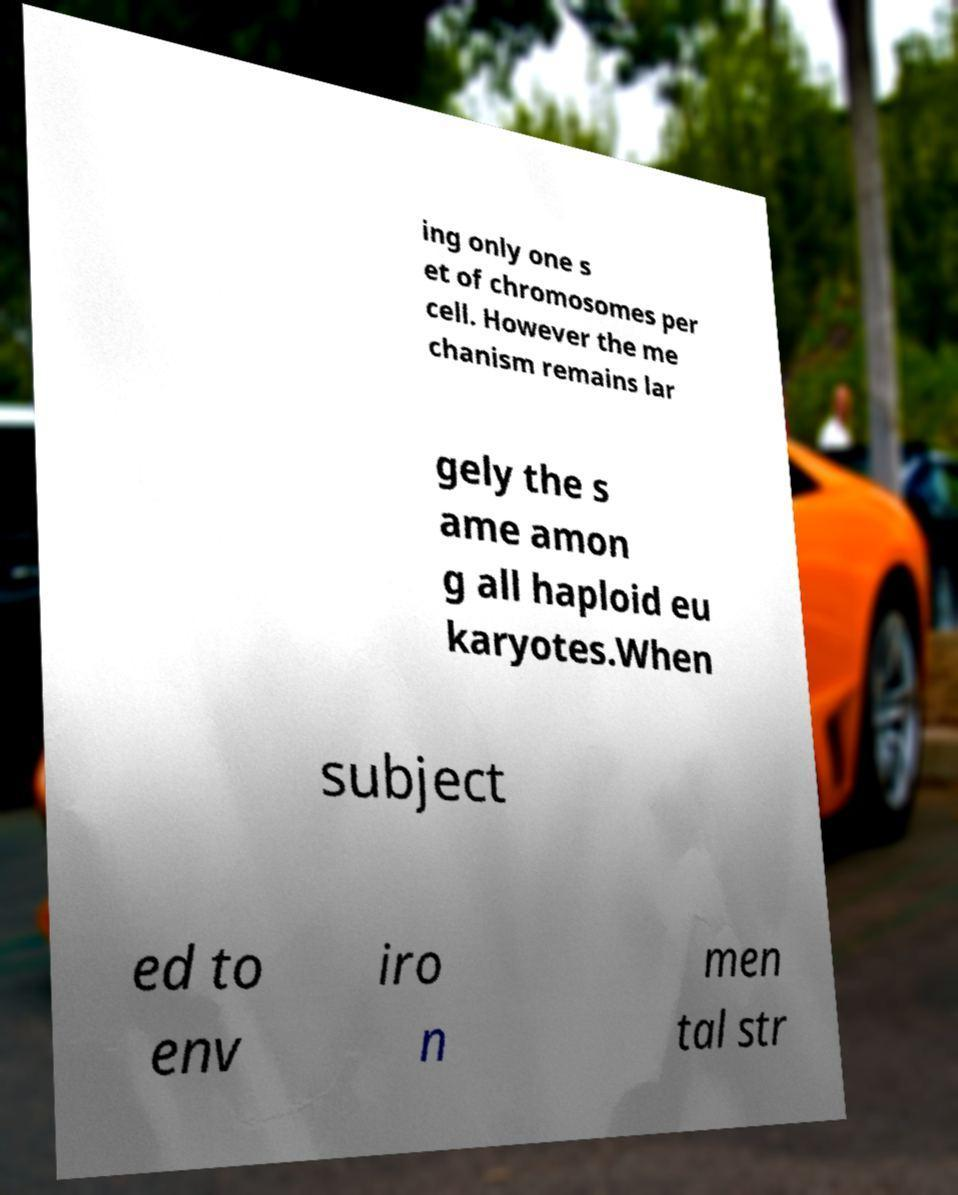Can you accurately transcribe the text from the provided image for me? ing only one s et of chromosomes per cell. However the me chanism remains lar gely the s ame amon g all haploid eu karyotes.When subject ed to env iro n men tal str 